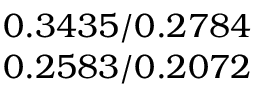Convert formula to latex. <formula><loc_0><loc_0><loc_500><loc_500>\begin{array} { c } { 0 . 3 4 3 5 / 0 . 2 7 8 4 } \\ { 0 . 2 5 8 3 / 0 . 2 0 7 2 } \end{array}</formula> 